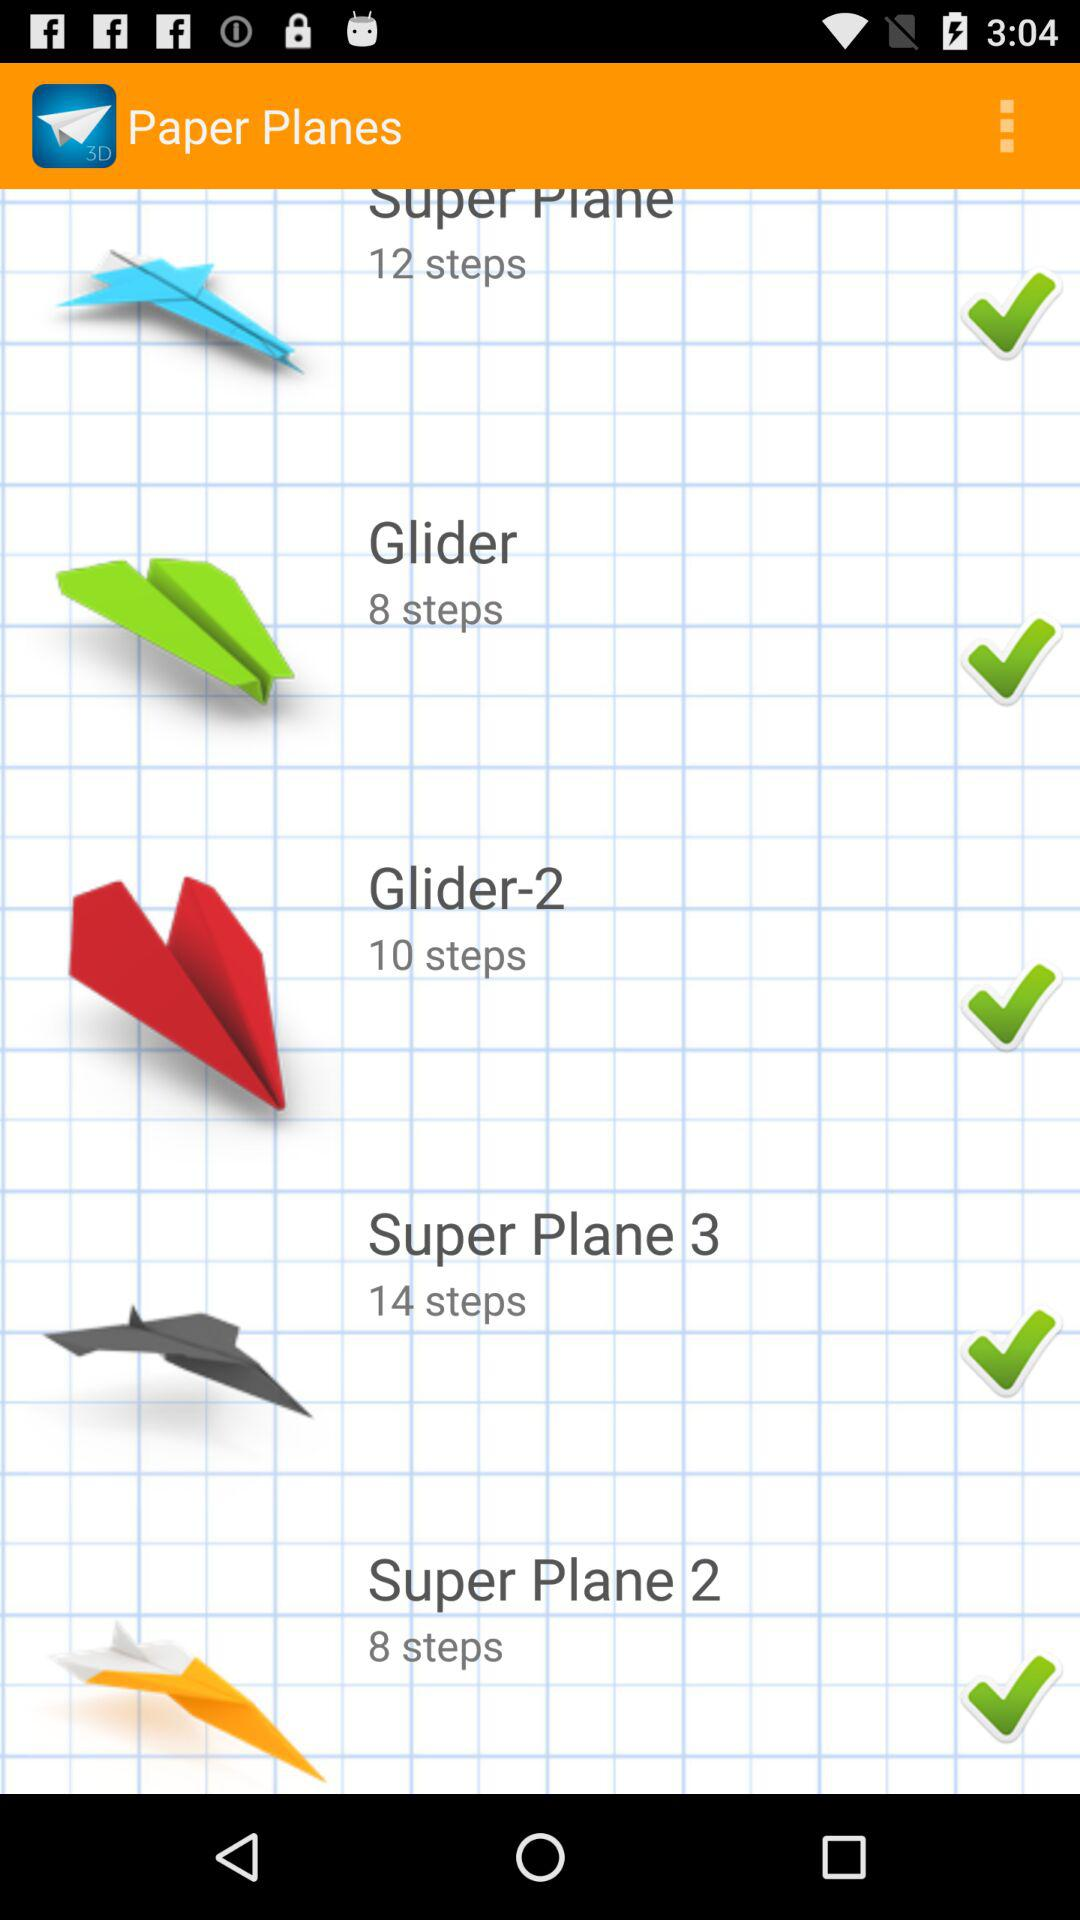How many steps have been counted in making "Glider-2" paper planes? The counted steps are 10. 